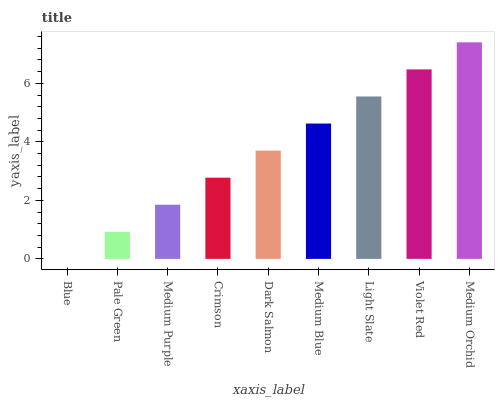Is Blue the minimum?
Answer yes or no. Yes. Is Medium Orchid the maximum?
Answer yes or no. Yes. Is Pale Green the minimum?
Answer yes or no. No. Is Pale Green the maximum?
Answer yes or no. No. Is Pale Green greater than Blue?
Answer yes or no. Yes. Is Blue less than Pale Green?
Answer yes or no. Yes. Is Blue greater than Pale Green?
Answer yes or no. No. Is Pale Green less than Blue?
Answer yes or no. No. Is Dark Salmon the high median?
Answer yes or no. Yes. Is Dark Salmon the low median?
Answer yes or no. Yes. Is Crimson the high median?
Answer yes or no. No. Is Blue the low median?
Answer yes or no. No. 